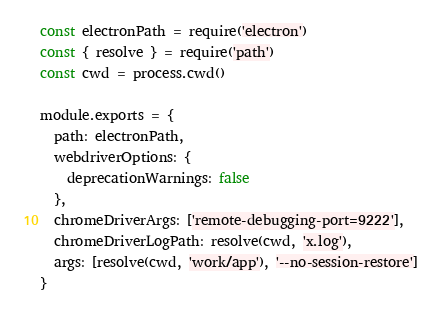Convert code to text. <code><loc_0><loc_0><loc_500><loc_500><_JavaScript_>
const electronPath = require('electron')
const { resolve } = require('path')
const cwd = process.cwd()

module.exports = {
  path: electronPath,
  webdriverOptions: {
    deprecationWarnings: false
  },
  chromeDriverArgs: ['remote-debugging-port=9222'],
  chromeDriverLogPath: resolve(cwd, 'x.log'),
  args: [resolve(cwd, 'work/app'), '--no-session-restore']
}
</code> 